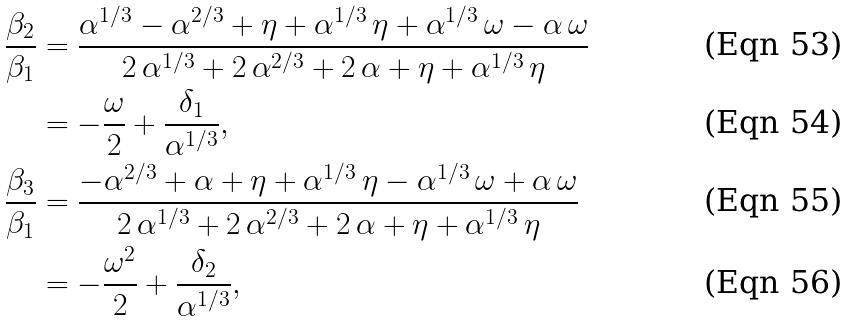<formula> <loc_0><loc_0><loc_500><loc_500>\frac { \beta _ { 2 } } { \beta _ { 1 } } & = \frac { { \alpha } ^ { 1 / 3 } - { \alpha } ^ { 2 / 3 } + \eta + { \alpha } ^ { 1 / 3 } \, \eta + { \alpha } ^ { 1 / 3 } \, \omega - \alpha \, \omega } { 2 \, { \alpha } ^ { 1 / 3 } + 2 \, { \alpha } ^ { 2 / 3 } + 2 \, \alpha + \eta + { \alpha } ^ { 1 / 3 } \, \eta } \\ & = - \frac { \omega } { 2 } + \frac { \delta _ { 1 } } { \alpha ^ { 1 / 3 } } , \\ \frac { \beta _ { 3 } } { \beta _ { 1 } } & = \frac { - { \alpha } ^ { 2 / 3 } + \alpha + \eta + { \alpha } ^ { 1 / 3 } \, \eta - { \alpha } ^ { 1 / 3 } \, \omega + \alpha \, \omega } { 2 \, { \alpha } ^ { 1 / 3 } + 2 \, { \alpha } ^ { 2 / 3 } + 2 \, \alpha + \eta + { \alpha } ^ { 1 / 3 } \, \eta } \\ & = - \frac { \omega ^ { 2 } } { 2 } + \frac { \delta _ { 2 } } { \alpha ^ { 1 / 3 } } ,</formula> 